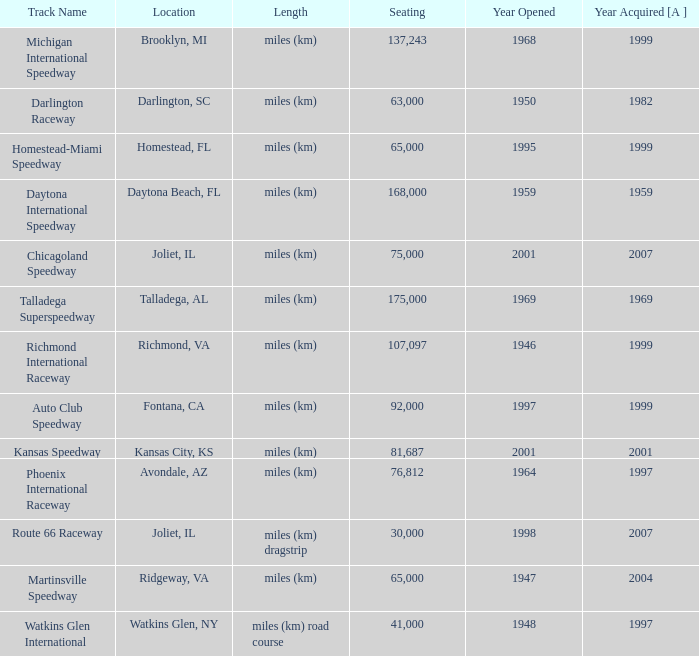What is the year opened for Chicagoland Speedway with a seating smaller than 75,000? None. 